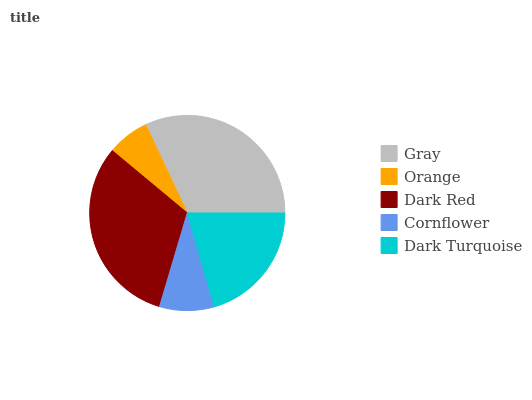Is Orange the minimum?
Answer yes or no. Yes. Is Gray the maximum?
Answer yes or no. Yes. Is Dark Red the minimum?
Answer yes or no. No. Is Dark Red the maximum?
Answer yes or no. No. Is Dark Red greater than Orange?
Answer yes or no. Yes. Is Orange less than Dark Red?
Answer yes or no. Yes. Is Orange greater than Dark Red?
Answer yes or no. No. Is Dark Red less than Orange?
Answer yes or no. No. Is Dark Turquoise the high median?
Answer yes or no. Yes. Is Dark Turquoise the low median?
Answer yes or no. Yes. Is Orange the high median?
Answer yes or no. No. Is Orange the low median?
Answer yes or no. No. 